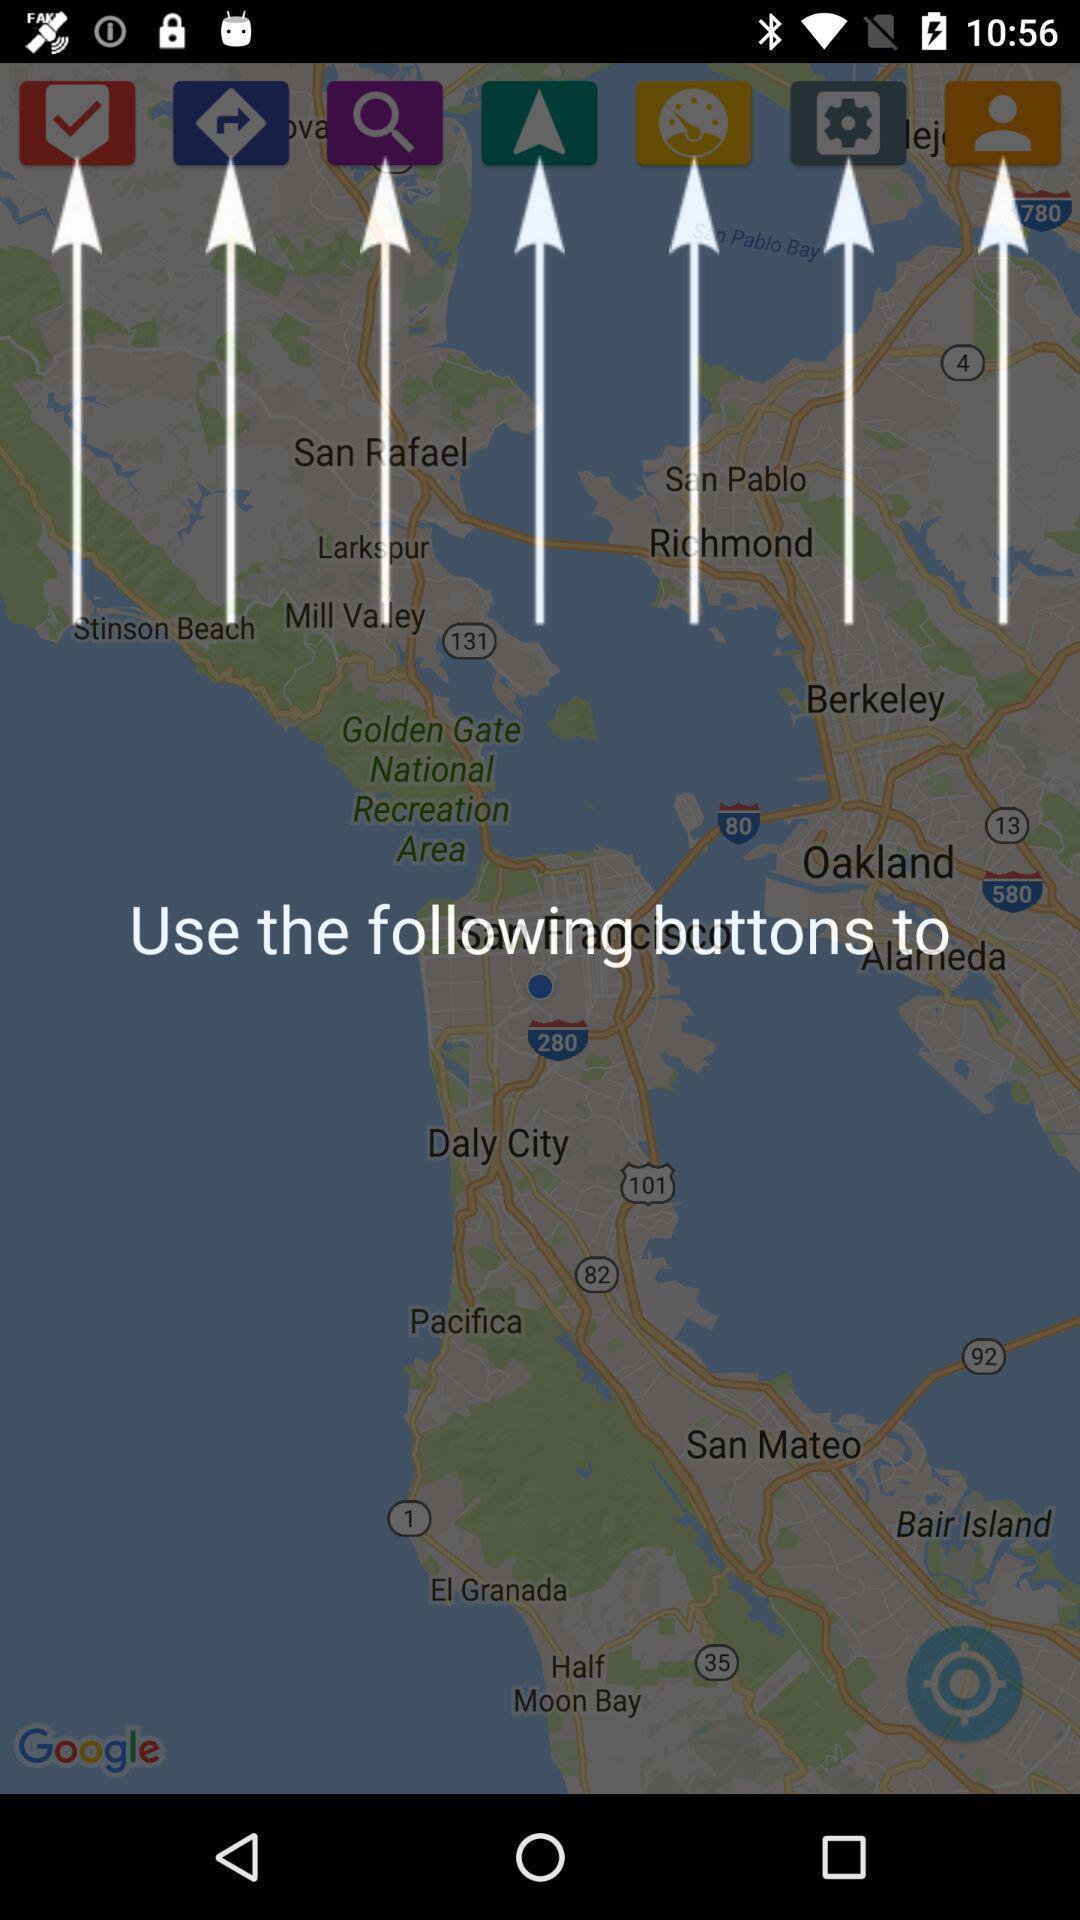Describe the visual elements of this screenshot. Page displays instructions to use app. 